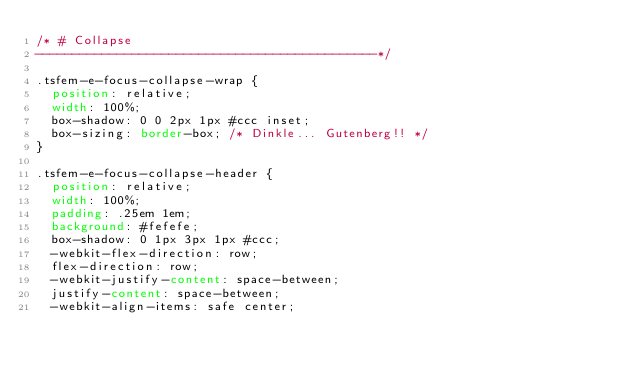<code> <loc_0><loc_0><loc_500><loc_500><_CSS_>/* # Collapse
----------------------------------------------*/

.tsfem-e-focus-collapse-wrap {
	position: relative;
	width: 100%;
	box-shadow: 0 0 2px 1px #ccc inset;
	box-sizing: border-box; /* Dinkle... Gutenberg!! */
}

.tsfem-e-focus-collapse-header {
	position: relative;
	width: 100%;
	padding: .25em 1em;
	background: #fefefe;
	box-shadow: 0 1px 3px 1px #ccc;
	-webkit-flex-direction: row;
	flex-direction: row;
	-webkit-justify-content: space-between;
	justify-content: space-between;
	-webkit-align-items: safe center;</code> 